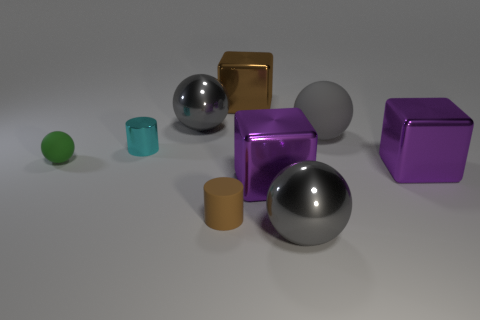Add 1 tiny green metallic objects. How many objects exist? 10 Subtract all large spheres. How many spheres are left? 1 Subtract all gray balls. How many balls are left? 1 Subtract 3 spheres. How many spheres are left? 1 Subtract all cylinders. How many objects are left? 7 Subtract all purple cylinders. How many purple cubes are left? 2 Subtract all brown cylinders. Subtract all red spheres. How many cylinders are left? 1 Subtract all big purple metallic objects. Subtract all gray metallic objects. How many objects are left? 5 Add 7 gray things. How many gray things are left? 10 Add 3 small brown rubber cylinders. How many small brown rubber cylinders exist? 4 